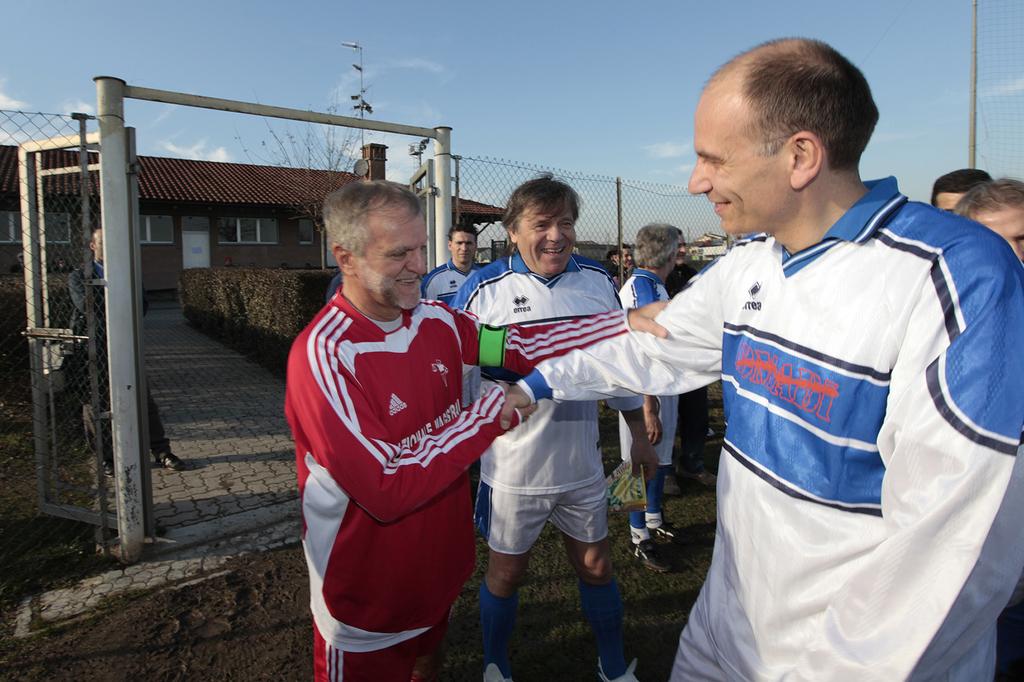Does the person on the left have adidas on their jacket?
Give a very brief answer. Yes. 